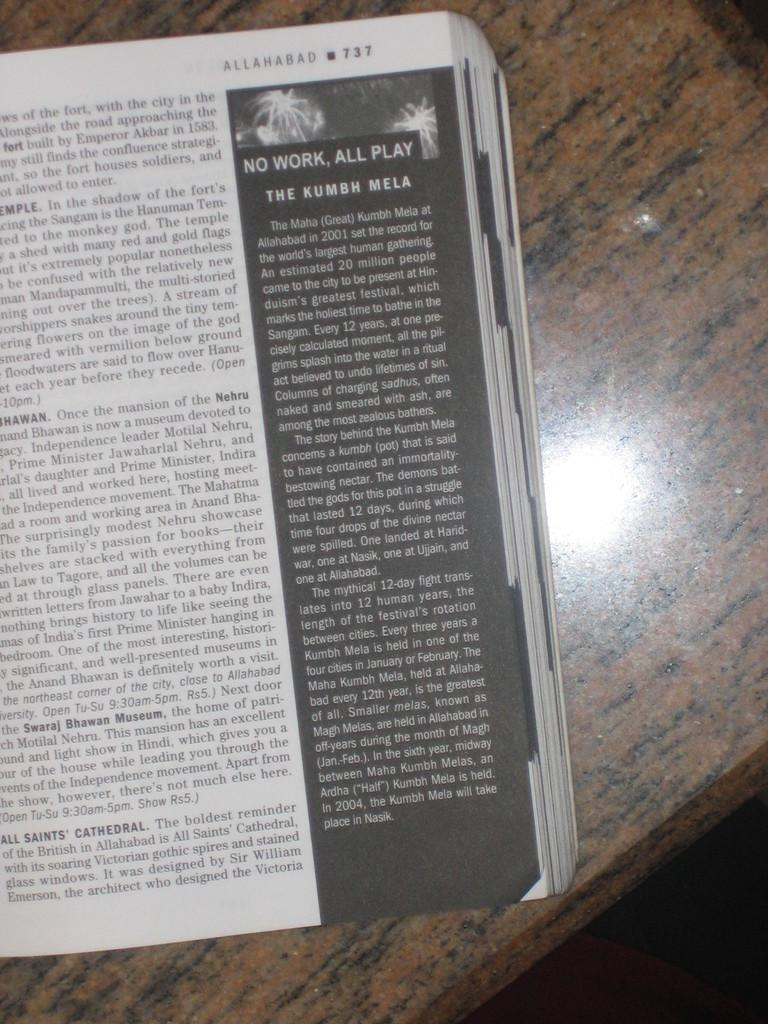<image>
Summarize the visual content of the image. A book is open to page 737 and the sidebar on that page is titled NO WORK, ALL PLAY. 